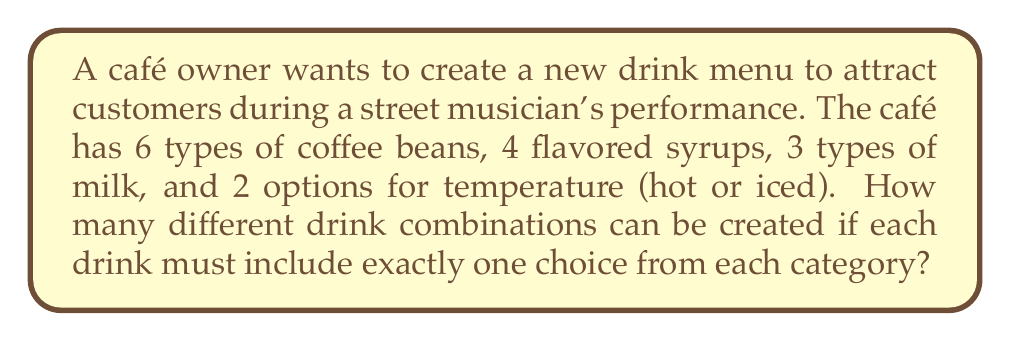Solve this math problem. Let's break this down step-by-step:

1) We have four categories of choices:
   - Coffee beans: 6 options
   - Flavored syrups: 4 options
   - Types of milk: 3 options
   - Temperature: 2 options

2) For each drink, we must choose one option from each category. This is a perfect scenario for applying the multiplication principle of counting.

3) The multiplication principle states that if we have $n$ independent events, and each event $i$ has $m_i$ possible outcomes, then the total number of possible outcomes for all events is the product of the number of outcomes for each event.

4) In this case, we have:
   - 6 choices for coffee beans
   - 4 choices for flavored syrup
   - 3 choices for milk
   - 2 choices for temperature

5) Therefore, the total number of possible drink combinations is:

   $$ 6 \times 4 \times 3 \times 2 = 144 $$

Thus, the café owner can create 144 different drink combinations to offer during the street musician's performance.
Answer: 144 